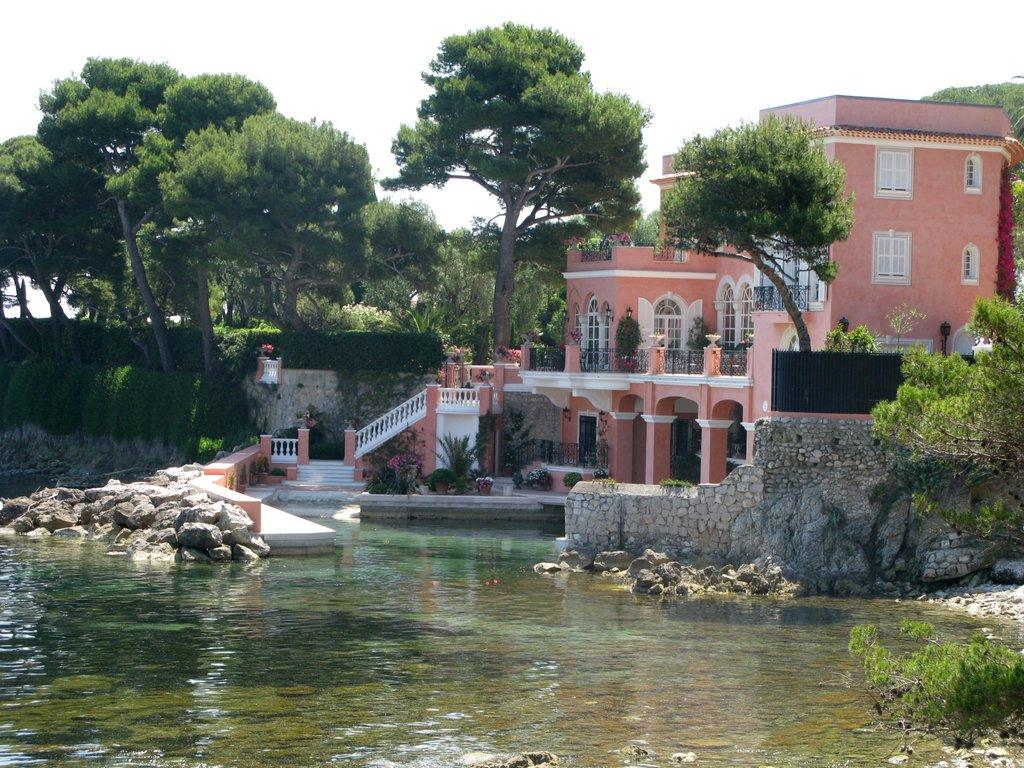What is the primary element visible in the image? There is water in the image. What other objects can be seen in the image? There are rocks, a wall, flower pots, and buildings in the image. What is visible in the background of the image? There are trees and the sky visible in the background of the image. What type of rings can be seen on the trees in the image? There are no rings visible on the trees in the image. 